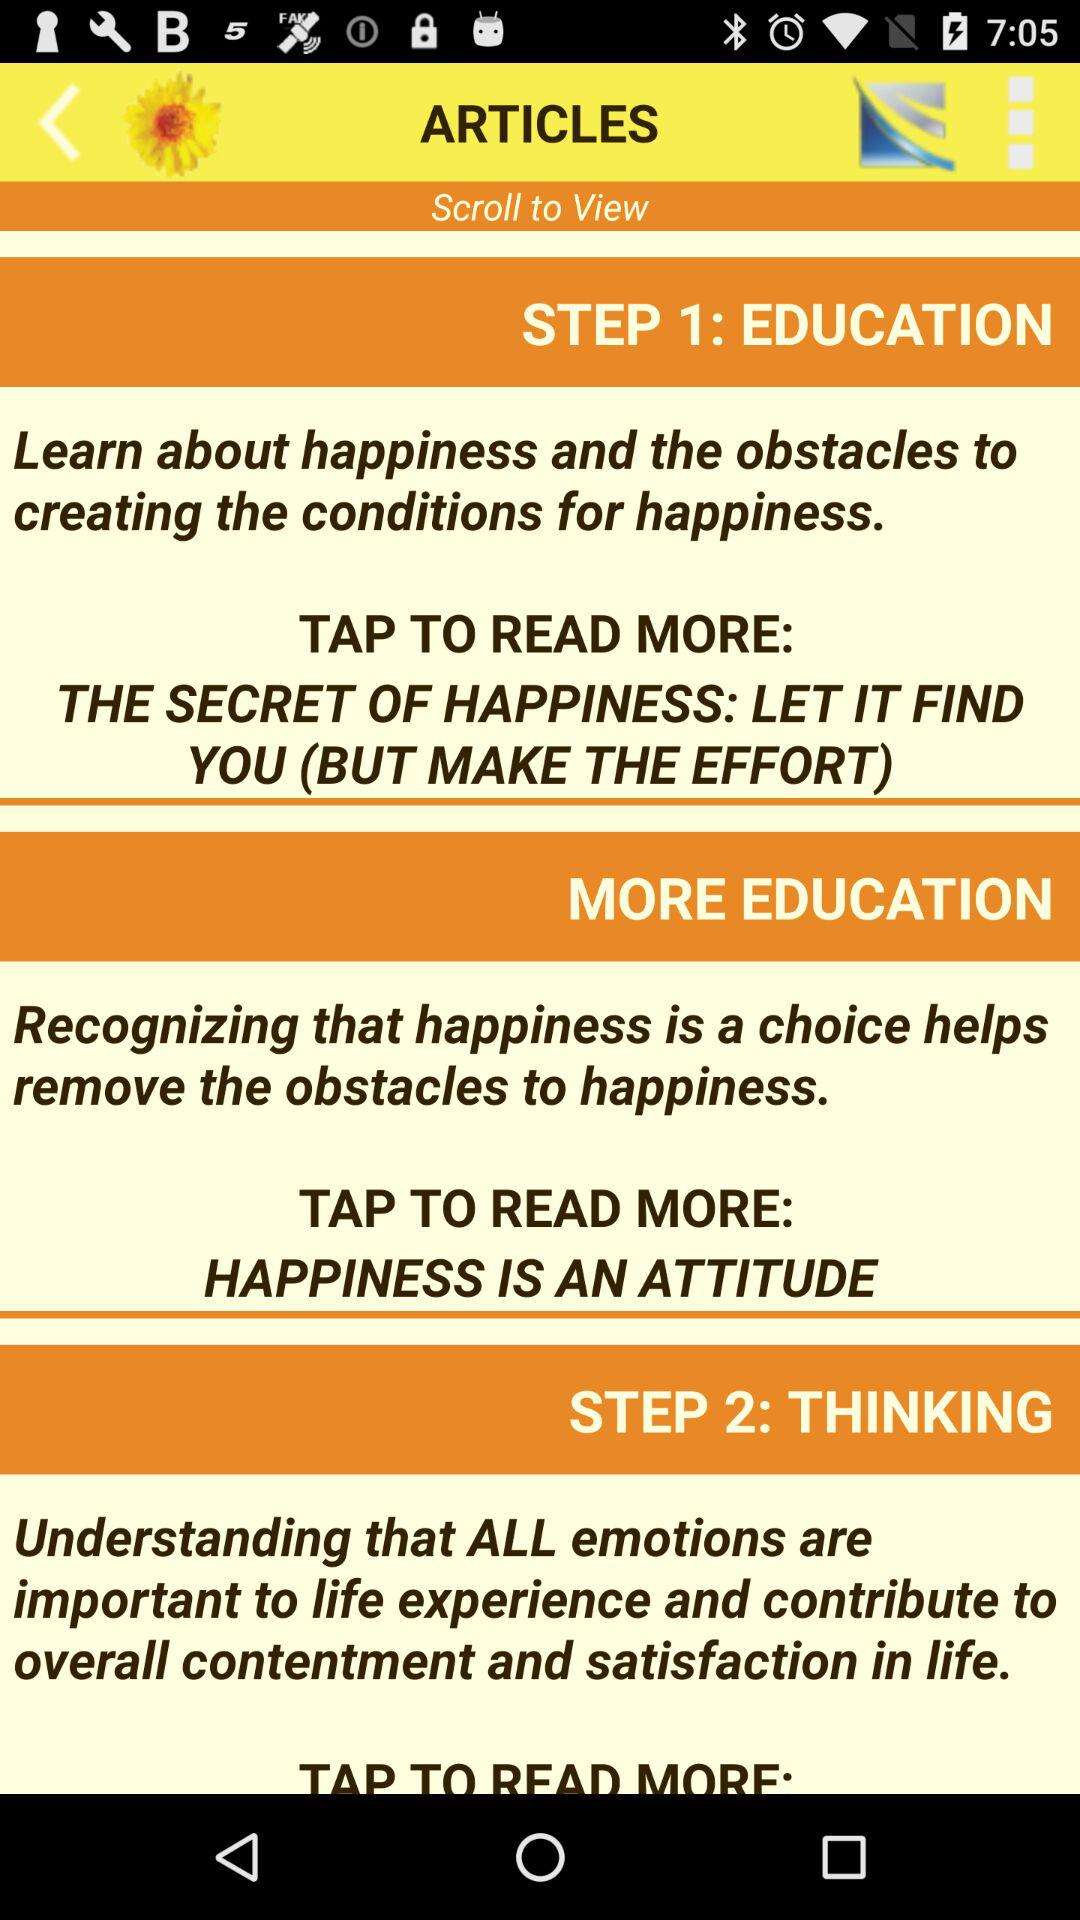What is the title of step 1? The title of step 1 is "EDUCATION". 